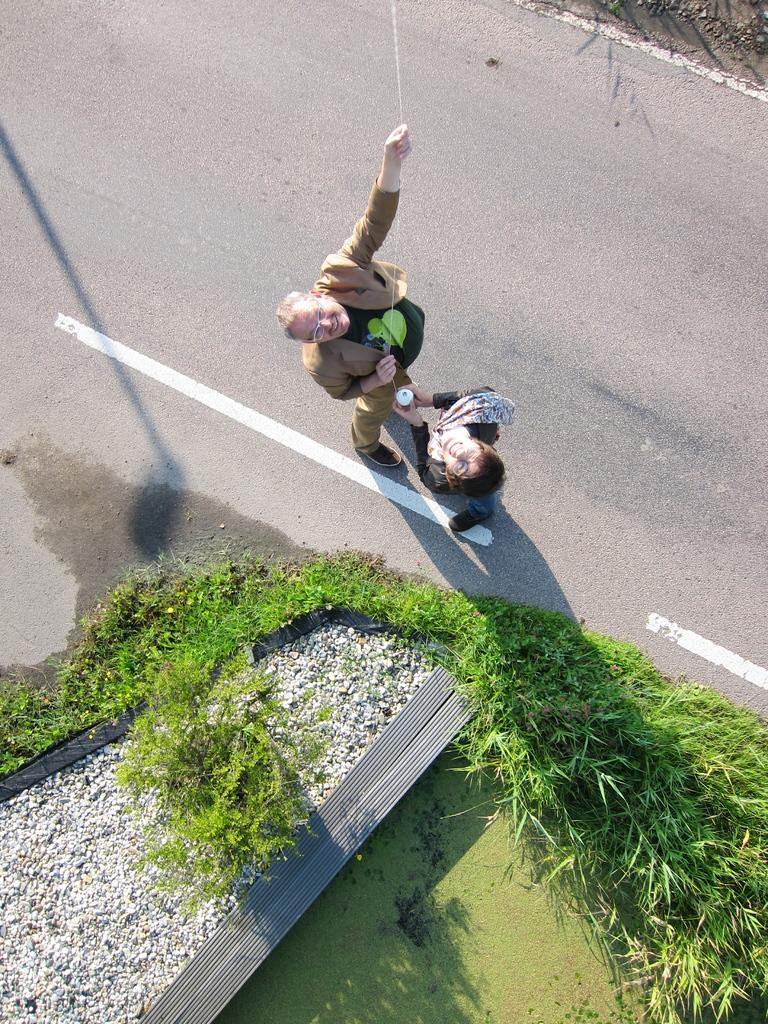How many people are in the image? There are two persons in the image. What are the persons doing in the image? The persons are standing and holding a thread in their hands. What can be seen in the background or surroundings of the persons? There is greenery grass beside them. What type of frame is visible around the persons in the image? There is no frame visible around the persons in the image. What time of day is it in the image, considering the presence of night? The image does not depict nighttime; there is no mention of darkness or night in the provided facts. 